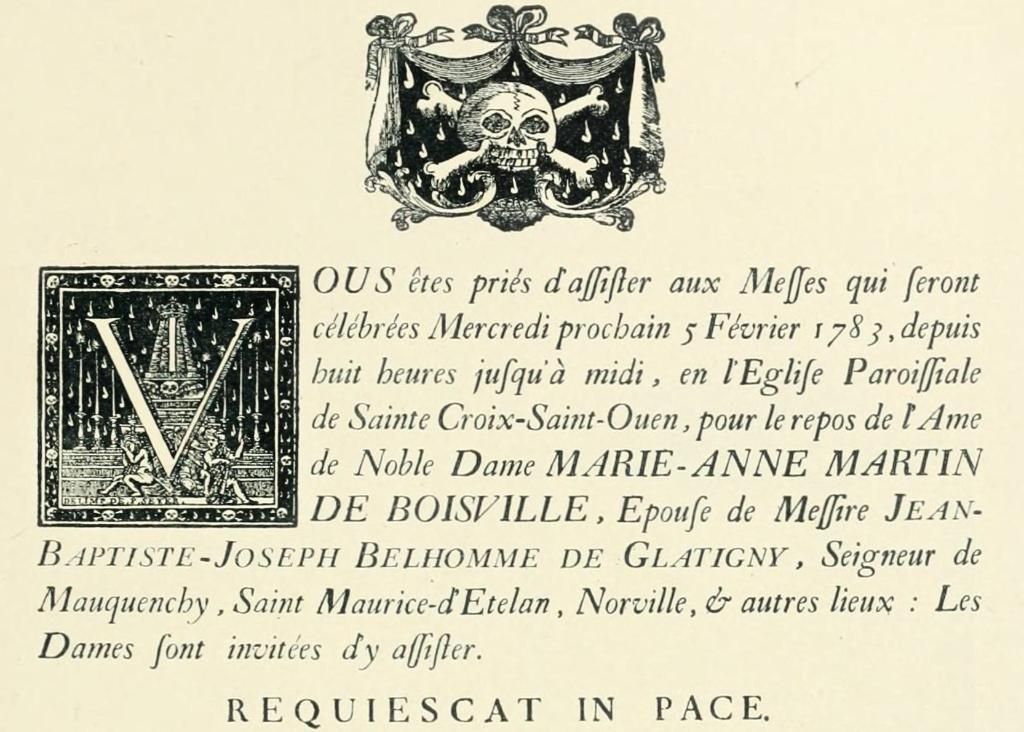What is featured in the image? There is a poster in the image. What can be found on the poster? The poster contains text. What else can be seen in the image besides the poster? There are toys in the image. What country is depicted on the poster? There is no country depicted on the poster; it only contains text. How many goldfish are swimming in the toys in the image? There are no goldfish present in the image; it only features a poster and toys. 